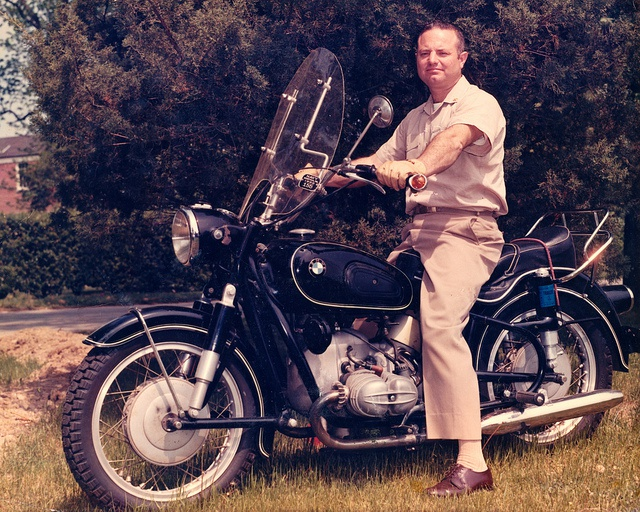Describe the objects in this image and their specific colors. I can see motorcycle in gray, black, purple, and navy tones and people in gray, lightpink, tan, brown, and beige tones in this image. 